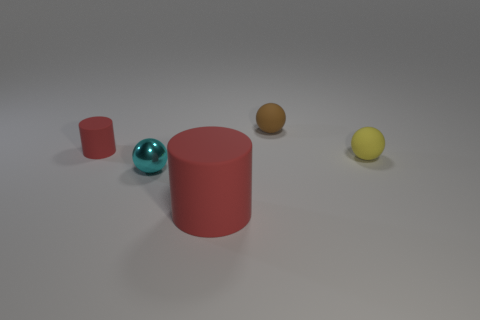Add 3 small red cubes. How many objects exist? 8 Subtract all cyan metal spheres. How many spheres are left? 2 Subtract all spheres. How many objects are left? 2 Subtract 1 spheres. How many spheres are left? 2 Subtract all brown spheres. How many spheres are left? 2 Subtract all purple cylinders. Subtract all gray spheres. How many cylinders are left? 2 Subtract all purple cubes. Subtract all small brown rubber things. How many objects are left? 4 Add 4 large rubber things. How many large rubber things are left? 5 Add 3 matte spheres. How many matte spheres exist? 5 Subtract 0 gray spheres. How many objects are left? 5 